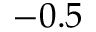Convert formula to latex. <formula><loc_0><loc_0><loc_500><loc_500>- 0 . 5</formula> 